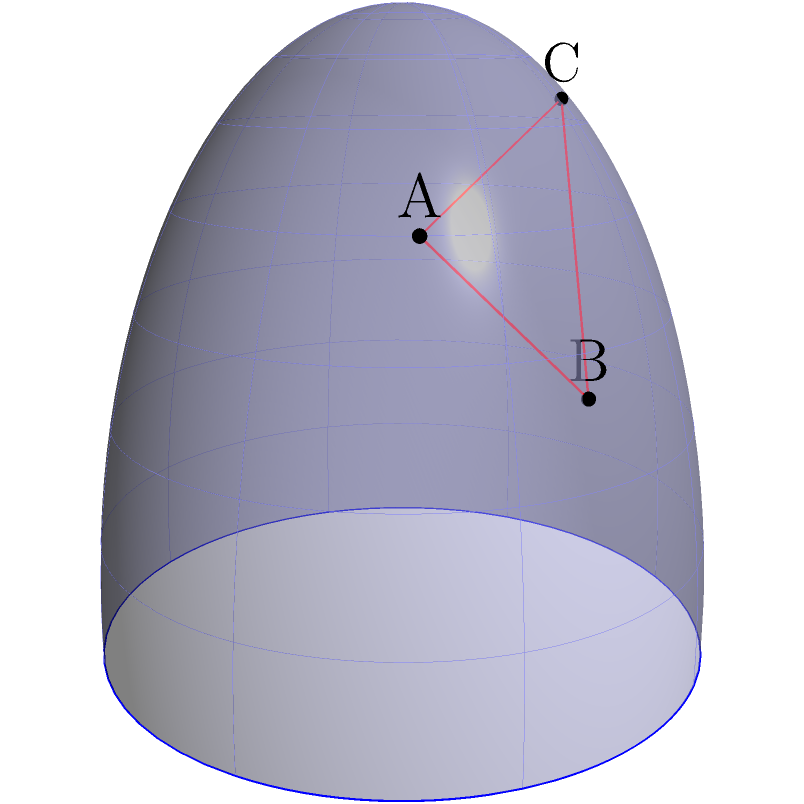In your celestial musings, you've discovered a poetic triangle formed by three stars on the celestial sphere. Given that star A has coordinates (π/6, π/4), star B has coordinates (π/3, π/6), and star C has coordinates (π/2, π/3) in the (azimuth, altitude) system, what is the perimeter of this celestial triangle in radians, rounded to two decimal places? (Assume the celestial sphere has a radius of 1 unit.) To find the perimeter of the celestial triangle, we need to calculate the great circle distances between each pair of stars and sum them up. Here's how we can do this step-by-step:

1) First, we need to convert the given coordinates to Cartesian coordinates on a unit sphere. The formula is:
   $x = \cos(\text{azimuth}) \cos(\text{altitude})$
   $y = \sin(\text{azimuth}) \cos(\text{altitude})$
   $z = \sin(\text{altitude})$

2) For star A (π/6, π/4):
   $A = (\cos(\pi/6)\cos(\pi/4), \sin(\pi/6)\cos(\pi/4), \sin(\pi/4))$
   $A \approx (0.6124, 0.3536, 0.7071)$

3) For star B (π/3, π/6):
   $B = (\cos(\pi/3)\cos(\pi/6), \sin(\pi/3)\cos(\pi/6), \sin(\pi/6))$
   $B \approx (0.4330, 0.7500, 0.5000)$

4) For star C (π/2, π/3):
   $C = (\cos(\pi/2)\cos(\pi/3), \sin(\pi/2)\cos(\pi/3), \sin(\pi/3))$
   $C \approx (0, 0.8660, 0.5000)$

5) To find the great circle distance between two points on a unit sphere, we use the arc cosine of their dot product:
   $d = \arccos(x_1x_2 + y_1y_2 + z_1z_2)$

6) Calculate distances:
   $AB = \arccos(0.6124 * 0.4330 + 0.3536 * 0.7500 + 0.7071 * 0.5000) \approx 0.5762$
   $BC = \arccos(0.4330 * 0 + 0.7500 * 0.8660 + 0.5000 * 0.5000) \approx 0.5236$
   $CA = \arccos(0 * 0.6124 + 0.8660 * 0.3536 + 0.5000 * 0.7071) \approx 0.8761$

7) The perimeter is the sum of these distances:
   $\text{Perimeter} = AB + BC + CA \approx 0.5762 + 0.5236 + 0.8761 = 1.9759$

8) Rounding to two decimal places: 1.98 radians.
Answer: 1.98 radians 